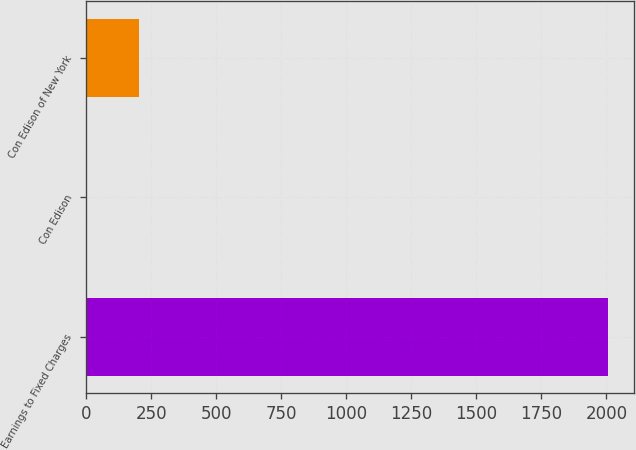Convert chart to OTSL. <chart><loc_0><loc_0><loc_500><loc_500><bar_chart><fcel>Earnings to Fixed Charges<fcel>Con Edison<fcel>Con Edison of New York<nl><fcel>2006<fcel>3<fcel>203.3<nl></chart> 